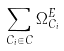Convert formula to latex. <formula><loc_0><loc_0><loc_500><loc_500>\sum _ { C _ { i } \in C } \Omega _ { C _ { i } } ^ { E }</formula> 